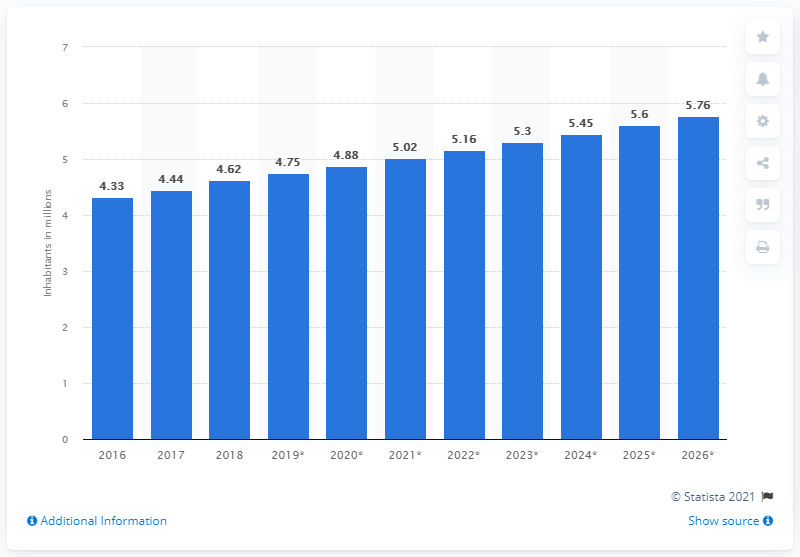How accurate are the projected population numbers on this chart for the years beyond 2018? The projected numbers for years beyond 2018 are estimations based on past trends and various demographic models. However, actual future populations may vary due to unforeseen factors such as significant policy changes, economic shifts, or health crises that could influence migration patterns and birth/death rates. 